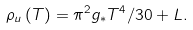<formula> <loc_0><loc_0><loc_500><loc_500>\rho _ { u } \left ( T \right ) = \pi ^ { 2 } g _ { \ast } T ^ { 4 } / 3 0 + L .</formula> 